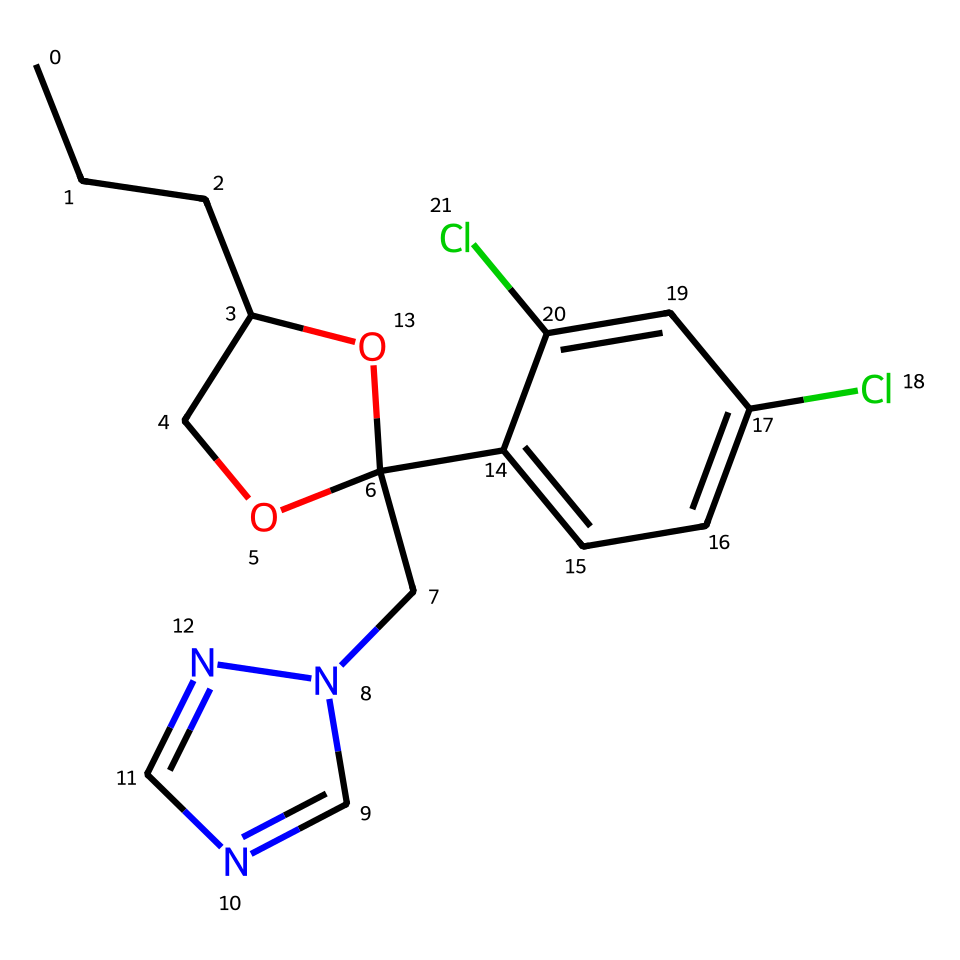What is the molecular formula of propiconazole? To determine the molecular formula, we need to count the different types of atoms present in the chemical structure, which are carbon (C), hydrogen (H), nitrogen (N), and chlorine (Cl). The chemical has a total of 16 carbon atoms, 20 hydrogen atoms, 2 nitrogen atoms, and 2 chlorine atoms. Hence, the molecular formula is C16H20Cl2N2O.
Answer: C16H20Cl2N2O How many chlorine atoms are in propiconazole? By examining the chemical structure or the provided SMILES, we see that there are two chlorine atoms attached as substituents on the aromatic ring.
Answer: 2 What functional groups are present in propiconazole? The structure shows several functional groups: a hydroxyl group (-OH), an alkoxy group (-O-), and a nitrogen-containing ring, indicating its fungicidal properties. Each functional group contributes to the properties of the molecule, especially its solubility and reactivity.
Answer: hydroxyl, alkoxy, nitrogen ring What type of chemical is propiconazole classified as? Propiconazole is classified as a triazole fungicide because it contains a triazole ring structure, which is typical for this category of fungicides used to control fungal pathogens.
Answer: triazole fungicide What is the significance of the nitrogen atoms in propiconazole? The nitrogen atoms in propiconazole are vital as they are part of the triazole ring, contributing to its mechanism of action against fungi by inhibiting the biosynthesis of ergosterol, a key component of fungal cell membranes.
Answer: mechanism of action Does propiconazole contain any aromatic rings? Observing the chemical structure, we see that there is indeed an aromatic ring, evidenced by the alternating double bonds between carbon atoms in that part of the molecule, which enhances its stability and biological activity.
Answer: yes 